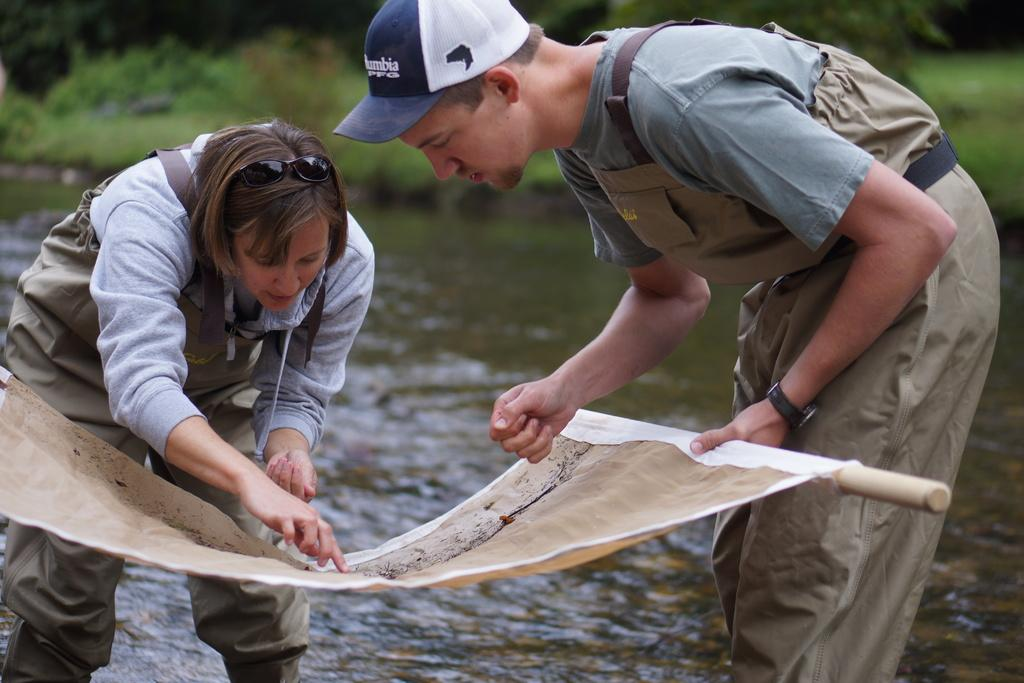How many people are present in the image? There are two people, a man and a woman, present in the image. What is the man holding in the image? The man is holding a piece of wood and a cloth in the image. What can be seen in the background of the image? There is water and greenery visible in the background of the image. How many sheets of paper are on the cent in the image? There is no cent or paper present in the image. 